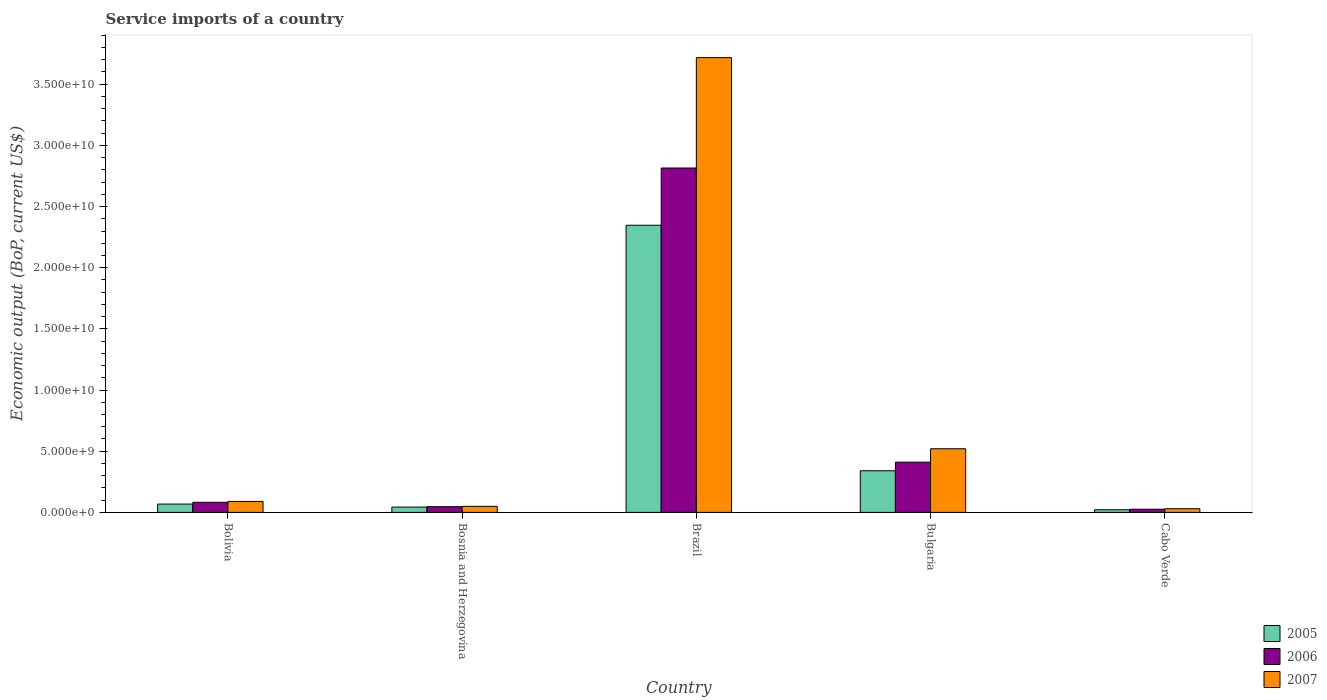How many different coloured bars are there?
Offer a very short reply. 3. How many bars are there on the 2nd tick from the left?
Provide a short and direct response. 3. How many bars are there on the 5th tick from the right?
Make the answer very short. 3. What is the label of the 5th group of bars from the left?
Provide a short and direct response. Cabo Verde. What is the service imports in 2006 in Bolivia?
Provide a short and direct response. 8.25e+08. Across all countries, what is the maximum service imports in 2005?
Provide a short and direct response. 2.35e+1. Across all countries, what is the minimum service imports in 2006?
Keep it short and to the point. 2.59e+08. In which country was the service imports in 2005 maximum?
Provide a short and direct response. Brazil. In which country was the service imports in 2006 minimum?
Make the answer very short. Cabo Verde. What is the total service imports in 2006 in the graph?
Provide a short and direct response. 3.38e+1. What is the difference between the service imports in 2005 in Bosnia and Herzegovina and that in Bulgaria?
Offer a very short reply. -2.97e+09. What is the difference between the service imports in 2005 in Bulgaria and the service imports in 2007 in Bolivia?
Offer a very short reply. 2.51e+09. What is the average service imports in 2006 per country?
Ensure brevity in your answer.  6.76e+09. What is the difference between the service imports of/in 2005 and service imports of/in 2006 in Bosnia and Herzegovina?
Your response must be concise. -3.12e+07. What is the ratio of the service imports in 2005 in Brazil to that in Cabo Verde?
Your answer should be compact. 109.36. Is the service imports in 2006 in Bolivia less than that in Cabo Verde?
Your answer should be compact. No. Is the difference between the service imports in 2005 in Bosnia and Herzegovina and Brazil greater than the difference between the service imports in 2006 in Bosnia and Herzegovina and Brazil?
Offer a terse response. Yes. What is the difference between the highest and the second highest service imports in 2007?
Your answer should be compact. 3.63e+1. What is the difference between the highest and the lowest service imports in 2005?
Offer a very short reply. 2.33e+1. Is it the case that in every country, the sum of the service imports in 2007 and service imports in 2006 is greater than the service imports in 2005?
Offer a very short reply. Yes. How many bars are there?
Provide a succinct answer. 15. Are all the bars in the graph horizontal?
Provide a short and direct response. No. How many countries are there in the graph?
Make the answer very short. 5. What is the difference between two consecutive major ticks on the Y-axis?
Make the answer very short. 5.00e+09. Are the values on the major ticks of Y-axis written in scientific E-notation?
Give a very brief answer. Yes. Does the graph contain any zero values?
Provide a short and direct response. No. How many legend labels are there?
Ensure brevity in your answer.  3. How are the legend labels stacked?
Your answer should be compact. Vertical. What is the title of the graph?
Offer a terse response. Service imports of a country. Does "1996" appear as one of the legend labels in the graph?
Offer a terse response. No. What is the label or title of the X-axis?
Your response must be concise. Country. What is the label or title of the Y-axis?
Make the answer very short. Economic output (BoP, current US$). What is the Economic output (BoP, current US$) of 2005 in Bolivia?
Your response must be concise. 6.82e+08. What is the Economic output (BoP, current US$) in 2006 in Bolivia?
Offer a very short reply. 8.25e+08. What is the Economic output (BoP, current US$) in 2007 in Bolivia?
Ensure brevity in your answer.  8.97e+08. What is the Economic output (BoP, current US$) of 2005 in Bosnia and Herzegovina?
Provide a succinct answer. 4.36e+08. What is the Economic output (BoP, current US$) of 2006 in Bosnia and Herzegovina?
Provide a succinct answer. 4.67e+08. What is the Economic output (BoP, current US$) in 2007 in Bosnia and Herzegovina?
Give a very brief answer. 4.95e+08. What is the Economic output (BoP, current US$) of 2005 in Brazil?
Give a very brief answer. 2.35e+1. What is the Economic output (BoP, current US$) of 2006 in Brazil?
Offer a very short reply. 2.81e+1. What is the Economic output (BoP, current US$) in 2007 in Brazil?
Offer a very short reply. 3.72e+1. What is the Economic output (BoP, current US$) of 2005 in Bulgaria?
Your response must be concise. 3.40e+09. What is the Economic output (BoP, current US$) of 2006 in Bulgaria?
Your answer should be very brief. 4.11e+09. What is the Economic output (BoP, current US$) in 2007 in Bulgaria?
Your answer should be compact. 5.20e+09. What is the Economic output (BoP, current US$) of 2005 in Cabo Verde?
Ensure brevity in your answer.  2.15e+08. What is the Economic output (BoP, current US$) of 2006 in Cabo Verde?
Ensure brevity in your answer.  2.59e+08. What is the Economic output (BoP, current US$) of 2007 in Cabo Verde?
Your answer should be compact. 3.02e+08. Across all countries, what is the maximum Economic output (BoP, current US$) of 2005?
Provide a short and direct response. 2.35e+1. Across all countries, what is the maximum Economic output (BoP, current US$) in 2006?
Give a very brief answer. 2.81e+1. Across all countries, what is the maximum Economic output (BoP, current US$) of 2007?
Provide a short and direct response. 3.72e+1. Across all countries, what is the minimum Economic output (BoP, current US$) in 2005?
Give a very brief answer. 2.15e+08. Across all countries, what is the minimum Economic output (BoP, current US$) in 2006?
Ensure brevity in your answer.  2.59e+08. Across all countries, what is the minimum Economic output (BoP, current US$) of 2007?
Provide a succinct answer. 3.02e+08. What is the total Economic output (BoP, current US$) of 2005 in the graph?
Your response must be concise. 2.82e+1. What is the total Economic output (BoP, current US$) of 2006 in the graph?
Your answer should be compact. 3.38e+1. What is the total Economic output (BoP, current US$) of 2007 in the graph?
Ensure brevity in your answer.  4.41e+1. What is the difference between the Economic output (BoP, current US$) in 2005 in Bolivia and that in Bosnia and Herzegovina?
Your answer should be very brief. 2.46e+08. What is the difference between the Economic output (BoP, current US$) of 2006 in Bolivia and that in Bosnia and Herzegovina?
Offer a terse response. 3.58e+08. What is the difference between the Economic output (BoP, current US$) in 2007 in Bolivia and that in Bosnia and Herzegovina?
Provide a short and direct response. 4.01e+08. What is the difference between the Economic output (BoP, current US$) of 2005 in Bolivia and that in Brazil?
Make the answer very short. -2.28e+1. What is the difference between the Economic output (BoP, current US$) in 2006 in Bolivia and that in Brazil?
Provide a short and direct response. -2.73e+1. What is the difference between the Economic output (BoP, current US$) in 2007 in Bolivia and that in Brazil?
Your response must be concise. -3.63e+1. What is the difference between the Economic output (BoP, current US$) in 2005 in Bolivia and that in Bulgaria?
Keep it short and to the point. -2.72e+09. What is the difference between the Economic output (BoP, current US$) of 2006 in Bolivia and that in Bulgaria?
Keep it short and to the point. -3.28e+09. What is the difference between the Economic output (BoP, current US$) in 2007 in Bolivia and that in Bulgaria?
Provide a succinct answer. -4.31e+09. What is the difference between the Economic output (BoP, current US$) of 2005 in Bolivia and that in Cabo Verde?
Give a very brief answer. 4.67e+08. What is the difference between the Economic output (BoP, current US$) of 2006 in Bolivia and that in Cabo Verde?
Ensure brevity in your answer.  5.66e+08. What is the difference between the Economic output (BoP, current US$) of 2007 in Bolivia and that in Cabo Verde?
Make the answer very short. 5.95e+08. What is the difference between the Economic output (BoP, current US$) in 2005 in Bosnia and Herzegovina and that in Brazil?
Provide a short and direct response. -2.30e+1. What is the difference between the Economic output (BoP, current US$) in 2006 in Bosnia and Herzegovina and that in Brazil?
Provide a succinct answer. -2.77e+1. What is the difference between the Economic output (BoP, current US$) of 2007 in Bosnia and Herzegovina and that in Brazil?
Offer a terse response. -3.67e+1. What is the difference between the Economic output (BoP, current US$) of 2005 in Bosnia and Herzegovina and that in Bulgaria?
Your answer should be very brief. -2.97e+09. What is the difference between the Economic output (BoP, current US$) in 2006 in Bosnia and Herzegovina and that in Bulgaria?
Offer a terse response. -3.64e+09. What is the difference between the Economic output (BoP, current US$) in 2007 in Bosnia and Herzegovina and that in Bulgaria?
Your answer should be very brief. -4.71e+09. What is the difference between the Economic output (BoP, current US$) in 2005 in Bosnia and Herzegovina and that in Cabo Verde?
Keep it short and to the point. 2.21e+08. What is the difference between the Economic output (BoP, current US$) of 2006 in Bosnia and Herzegovina and that in Cabo Verde?
Provide a succinct answer. 2.08e+08. What is the difference between the Economic output (BoP, current US$) of 2007 in Bosnia and Herzegovina and that in Cabo Verde?
Provide a short and direct response. 1.94e+08. What is the difference between the Economic output (BoP, current US$) of 2005 in Brazil and that in Bulgaria?
Your answer should be compact. 2.01e+1. What is the difference between the Economic output (BoP, current US$) in 2006 in Brazil and that in Bulgaria?
Provide a succinct answer. 2.40e+1. What is the difference between the Economic output (BoP, current US$) of 2007 in Brazil and that in Bulgaria?
Give a very brief answer. 3.20e+1. What is the difference between the Economic output (BoP, current US$) of 2005 in Brazil and that in Cabo Verde?
Provide a short and direct response. 2.33e+1. What is the difference between the Economic output (BoP, current US$) in 2006 in Brazil and that in Cabo Verde?
Your answer should be very brief. 2.79e+1. What is the difference between the Economic output (BoP, current US$) of 2007 in Brazil and that in Cabo Verde?
Ensure brevity in your answer.  3.69e+1. What is the difference between the Economic output (BoP, current US$) of 2005 in Bulgaria and that in Cabo Verde?
Your answer should be compact. 3.19e+09. What is the difference between the Economic output (BoP, current US$) of 2006 in Bulgaria and that in Cabo Verde?
Offer a terse response. 3.85e+09. What is the difference between the Economic output (BoP, current US$) in 2007 in Bulgaria and that in Cabo Verde?
Provide a succinct answer. 4.90e+09. What is the difference between the Economic output (BoP, current US$) in 2005 in Bolivia and the Economic output (BoP, current US$) in 2006 in Bosnia and Herzegovina?
Your answer should be compact. 2.15e+08. What is the difference between the Economic output (BoP, current US$) of 2005 in Bolivia and the Economic output (BoP, current US$) of 2007 in Bosnia and Herzegovina?
Give a very brief answer. 1.87e+08. What is the difference between the Economic output (BoP, current US$) of 2006 in Bolivia and the Economic output (BoP, current US$) of 2007 in Bosnia and Herzegovina?
Provide a succinct answer. 3.29e+08. What is the difference between the Economic output (BoP, current US$) of 2005 in Bolivia and the Economic output (BoP, current US$) of 2006 in Brazil?
Your answer should be compact. -2.75e+1. What is the difference between the Economic output (BoP, current US$) in 2005 in Bolivia and the Economic output (BoP, current US$) in 2007 in Brazil?
Give a very brief answer. -3.65e+1. What is the difference between the Economic output (BoP, current US$) in 2006 in Bolivia and the Economic output (BoP, current US$) in 2007 in Brazil?
Your response must be concise. -3.63e+1. What is the difference between the Economic output (BoP, current US$) in 2005 in Bolivia and the Economic output (BoP, current US$) in 2006 in Bulgaria?
Give a very brief answer. -3.42e+09. What is the difference between the Economic output (BoP, current US$) in 2005 in Bolivia and the Economic output (BoP, current US$) in 2007 in Bulgaria?
Your response must be concise. -4.52e+09. What is the difference between the Economic output (BoP, current US$) in 2006 in Bolivia and the Economic output (BoP, current US$) in 2007 in Bulgaria?
Ensure brevity in your answer.  -4.38e+09. What is the difference between the Economic output (BoP, current US$) in 2005 in Bolivia and the Economic output (BoP, current US$) in 2006 in Cabo Verde?
Make the answer very short. 4.23e+08. What is the difference between the Economic output (BoP, current US$) of 2005 in Bolivia and the Economic output (BoP, current US$) of 2007 in Cabo Verde?
Provide a short and direct response. 3.80e+08. What is the difference between the Economic output (BoP, current US$) of 2006 in Bolivia and the Economic output (BoP, current US$) of 2007 in Cabo Verde?
Ensure brevity in your answer.  5.23e+08. What is the difference between the Economic output (BoP, current US$) in 2005 in Bosnia and Herzegovina and the Economic output (BoP, current US$) in 2006 in Brazil?
Make the answer very short. -2.77e+1. What is the difference between the Economic output (BoP, current US$) in 2005 in Bosnia and Herzegovina and the Economic output (BoP, current US$) in 2007 in Brazil?
Your response must be concise. -3.67e+1. What is the difference between the Economic output (BoP, current US$) of 2006 in Bosnia and Herzegovina and the Economic output (BoP, current US$) of 2007 in Brazil?
Your response must be concise. -3.67e+1. What is the difference between the Economic output (BoP, current US$) in 2005 in Bosnia and Herzegovina and the Economic output (BoP, current US$) in 2006 in Bulgaria?
Offer a very short reply. -3.67e+09. What is the difference between the Economic output (BoP, current US$) of 2005 in Bosnia and Herzegovina and the Economic output (BoP, current US$) of 2007 in Bulgaria?
Offer a terse response. -4.77e+09. What is the difference between the Economic output (BoP, current US$) in 2006 in Bosnia and Herzegovina and the Economic output (BoP, current US$) in 2007 in Bulgaria?
Offer a very short reply. -4.74e+09. What is the difference between the Economic output (BoP, current US$) of 2005 in Bosnia and Herzegovina and the Economic output (BoP, current US$) of 2006 in Cabo Verde?
Provide a short and direct response. 1.77e+08. What is the difference between the Economic output (BoP, current US$) of 2005 in Bosnia and Herzegovina and the Economic output (BoP, current US$) of 2007 in Cabo Verde?
Provide a short and direct response. 1.34e+08. What is the difference between the Economic output (BoP, current US$) in 2006 in Bosnia and Herzegovina and the Economic output (BoP, current US$) in 2007 in Cabo Verde?
Offer a very short reply. 1.65e+08. What is the difference between the Economic output (BoP, current US$) of 2005 in Brazil and the Economic output (BoP, current US$) of 2006 in Bulgaria?
Provide a succinct answer. 1.94e+1. What is the difference between the Economic output (BoP, current US$) of 2005 in Brazil and the Economic output (BoP, current US$) of 2007 in Bulgaria?
Your response must be concise. 1.83e+1. What is the difference between the Economic output (BoP, current US$) of 2006 in Brazil and the Economic output (BoP, current US$) of 2007 in Bulgaria?
Offer a very short reply. 2.29e+1. What is the difference between the Economic output (BoP, current US$) of 2005 in Brazil and the Economic output (BoP, current US$) of 2006 in Cabo Verde?
Give a very brief answer. 2.32e+1. What is the difference between the Economic output (BoP, current US$) of 2005 in Brazil and the Economic output (BoP, current US$) of 2007 in Cabo Verde?
Offer a terse response. 2.32e+1. What is the difference between the Economic output (BoP, current US$) in 2006 in Brazil and the Economic output (BoP, current US$) in 2007 in Cabo Verde?
Offer a terse response. 2.78e+1. What is the difference between the Economic output (BoP, current US$) of 2005 in Bulgaria and the Economic output (BoP, current US$) of 2006 in Cabo Verde?
Keep it short and to the point. 3.14e+09. What is the difference between the Economic output (BoP, current US$) in 2005 in Bulgaria and the Economic output (BoP, current US$) in 2007 in Cabo Verde?
Your answer should be compact. 3.10e+09. What is the difference between the Economic output (BoP, current US$) in 2006 in Bulgaria and the Economic output (BoP, current US$) in 2007 in Cabo Verde?
Your response must be concise. 3.80e+09. What is the average Economic output (BoP, current US$) of 2005 per country?
Make the answer very short. 5.64e+09. What is the average Economic output (BoP, current US$) of 2006 per country?
Your response must be concise. 6.76e+09. What is the average Economic output (BoP, current US$) of 2007 per country?
Provide a short and direct response. 8.81e+09. What is the difference between the Economic output (BoP, current US$) of 2005 and Economic output (BoP, current US$) of 2006 in Bolivia?
Your answer should be compact. -1.43e+08. What is the difference between the Economic output (BoP, current US$) in 2005 and Economic output (BoP, current US$) in 2007 in Bolivia?
Your response must be concise. -2.15e+08. What is the difference between the Economic output (BoP, current US$) in 2006 and Economic output (BoP, current US$) in 2007 in Bolivia?
Keep it short and to the point. -7.19e+07. What is the difference between the Economic output (BoP, current US$) of 2005 and Economic output (BoP, current US$) of 2006 in Bosnia and Herzegovina?
Keep it short and to the point. -3.12e+07. What is the difference between the Economic output (BoP, current US$) in 2005 and Economic output (BoP, current US$) in 2007 in Bosnia and Herzegovina?
Provide a short and direct response. -5.97e+07. What is the difference between the Economic output (BoP, current US$) of 2006 and Economic output (BoP, current US$) of 2007 in Bosnia and Herzegovina?
Provide a succinct answer. -2.86e+07. What is the difference between the Economic output (BoP, current US$) in 2005 and Economic output (BoP, current US$) in 2006 in Brazil?
Offer a very short reply. -4.68e+09. What is the difference between the Economic output (BoP, current US$) in 2005 and Economic output (BoP, current US$) in 2007 in Brazil?
Provide a succinct answer. -1.37e+1. What is the difference between the Economic output (BoP, current US$) of 2006 and Economic output (BoP, current US$) of 2007 in Brazil?
Give a very brief answer. -9.02e+09. What is the difference between the Economic output (BoP, current US$) in 2005 and Economic output (BoP, current US$) in 2006 in Bulgaria?
Make the answer very short. -7.02e+08. What is the difference between the Economic output (BoP, current US$) of 2005 and Economic output (BoP, current US$) of 2007 in Bulgaria?
Your answer should be compact. -1.80e+09. What is the difference between the Economic output (BoP, current US$) in 2006 and Economic output (BoP, current US$) in 2007 in Bulgaria?
Provide a short and direct response. -1.10e+09. What is the difference between the Economic output (BoP, current US$) in 2005 and Economic output (BoP, current US$) in 2006 in Cabo Verde?
Your answer should be compact. -4.44e+07. What is the difference between the Economic output (BoP, current US$) in 2005 and Economic output (BoP, current US$) in 2007 in Cabo Verde?
Your answer should be very brief. -8.69e+07. What is the difference between the Economic output (BoP, current US$) in 2006 and Economic output (BoP, current US$) in 2007 in Cabo Verde?
Give a very brief answer. -4.25e+07. What is the ratio of the Economic output (BoP, current US$) of 2005 in Bolivia to that in Bosnia and Herzegovina?
Keep it short and to the point. 1.57. What is the ratio of the Economic output (BoP, current US$) in 2006 in Bolivia to that in Bosnia and Herzegovina?
Make the answer very short. 1.77. What is the ratio of the Economic output (BoP, current US$) in 2007 in Bolivia to that in Bosnia and Herzegovina?
Keep it short and to the point. 1.81. What is the ratio of the Economic output (BoP, current US$) of 2005 in Bolivia to that in Brazil?
Provide a succinct answer. 0.03. What is the ratio of the Economic output (BoP, current US$) of 2006 in Bolivia to that in Brazil?
Keep it short and to the point. 0.03. What is the ratio of the Economic output (BoP, current US$) of 2007 in Bolivia to that in Brazil?
Provide a short and direct response. 0.02. What is the ratio of the Economic output (BoP, current US$) of 2005 in Bolivia to that in Bulgaria?
Give a very brief answer. 0.2. What is the ratio of the Economic output (BoP, current US$) in 2006 in Bolivia to that in Bulgaria?
Keep it short and to the point. 0.2. What is the ratio of the Economic output (BoP, current US$) in 2007 in Bolivia to that in Bulgaria?
Offer a terse response. 0.17. What is the ratio of the Economic output (BoP, current US$) in 2005 in Bolivia to that in Cabo Verde?
Offer a terse response. 3.18. What is the ratio of the Economic output (BoP, current US$) in 2006 in Bolivia to that in Cabo Verde?
Keep it short and to the point. 3.18. What is the ratio of the Economic output (BoP, current US$) of 2007 in Bolivia to that in Cabo Verde?
Give a very brief answer. 2.97. What is the ratio of the Economic output (BoP, current US$) in 2005 in Bosnia and Herzegovina to that in Brazil?
Offer a very short reply. 0.02. What is the ratio of the Economic output (BoP, current US$) in 2006 in Bosnia and Herzegovina to that in Brazil?
Ensure brevity in your answer.  0.02. What is the ratio of the Economic output (BoP, current US$) of 2007 in Bosnia and Herzegovina to that in Brazil?
Your answer should be compact. 0.01. What is the ratio of the Economic output (BoP, current US$) in 2005 in Bosnia and Herzegovina to that in Bulgaria?
Your answer should be compact. 0.13. What is the ratio of the Economic output (BoP, current US$) in 2006 in Bosnia and Herzegovina to that in Bulgaria?
Ensure brevity in your answer.  0.11. What is the ratio of the Economic output (BoP, current US$) of 2007 in Bosnia and Herzegovina to that in Bulgaria?
Give a very brief answer. 0.1. What is the ratio of the Economic output (BoP, current US$) of 2005 in Bosnia and Herzegovina to that in Cabo Verde?
Make the answer very short. 2.03. What is the ratio of the Economic output (BoP, current US$) of 2006 in Bosnia and Herzegovina to that in Cabo Verde?
Your response must be concise. 1.8. What is the ratio of the Economic output (BoP, current US$) of 2007 in Bosnia and Herzegovina to that in Cabo Verde?
Your answer should be very brief. 1.64. What is the ratio of the Economic output (BoP, current US$) of 2005 in Brazil to that in Bulgaria?
Your answer should be very brief. 6.9. What is the ratio of the Economic output (BoP, current US$) in 2006 in Brazil to that in Bulgaria?
Offer a very short reply. 6.86. What is the ratio of the Economic output (BoP, current US$) in 2007 in Brazil to that in Bulgaria?
Offer a very short reply. 7.15. What is the ratio of the Economic output (BoP, current US$) of 2005 in Brazil to that in Cabo Verde?
Offer a terse response. 109.36. What is the ratio of the Economic output (BoP, current US$) in 2006 in Brazil to that in Cabo Verde?
Ensure brevity in your answer.  108.66. What is the ratio of the Economic output (BoP, current US$) in 2007 in Brazil to that in Cabo Verde?
Provide a succinct answer. 123.27. What is the ratio of the Economic output (BoP, current US$) in 2005 in Bulgaria to that in Cabo Verde?
Your response must be concise. 15.86. What is the ratio of the Economic output (BoP, current US$) in 2006 in Bulgaria to that in Cabo Verde?
Ensure brevity in your answer.  15.85. What is the ratio of the Economic output (BoP, current US$) in 2007 in Bulgaria to that in Cabo Verde?
Provide a succinct answer. 17.25. What is the difference between the highest and the second highest Economic output (BoP, current US$) in 2005?
Your response must be concise. 2.01e+1. What is the difference between the highest and the second highest Economic output (BoP, current US$) of 2006?
Your response must be concise. 2.40e+1. What is the difference between the highest and the second highest Economic output (BoP, current US$) of 2007?
Your response must be concise. 3.20e+1. What is the difference between the highest and the lowest Economic output (BoP, current US$) in 2005?
Your response must be concise. 2.33e+1. What is the difference between the highest and the lowest Economic output (BoP, current US$) of 2006?
Ensure brevity in your answer.  2.79e+1. What is the difference between the highest and the lowest Economic output (BoP, current US$) of 2007?
Your answer should be very brief. 3.69e+1. 